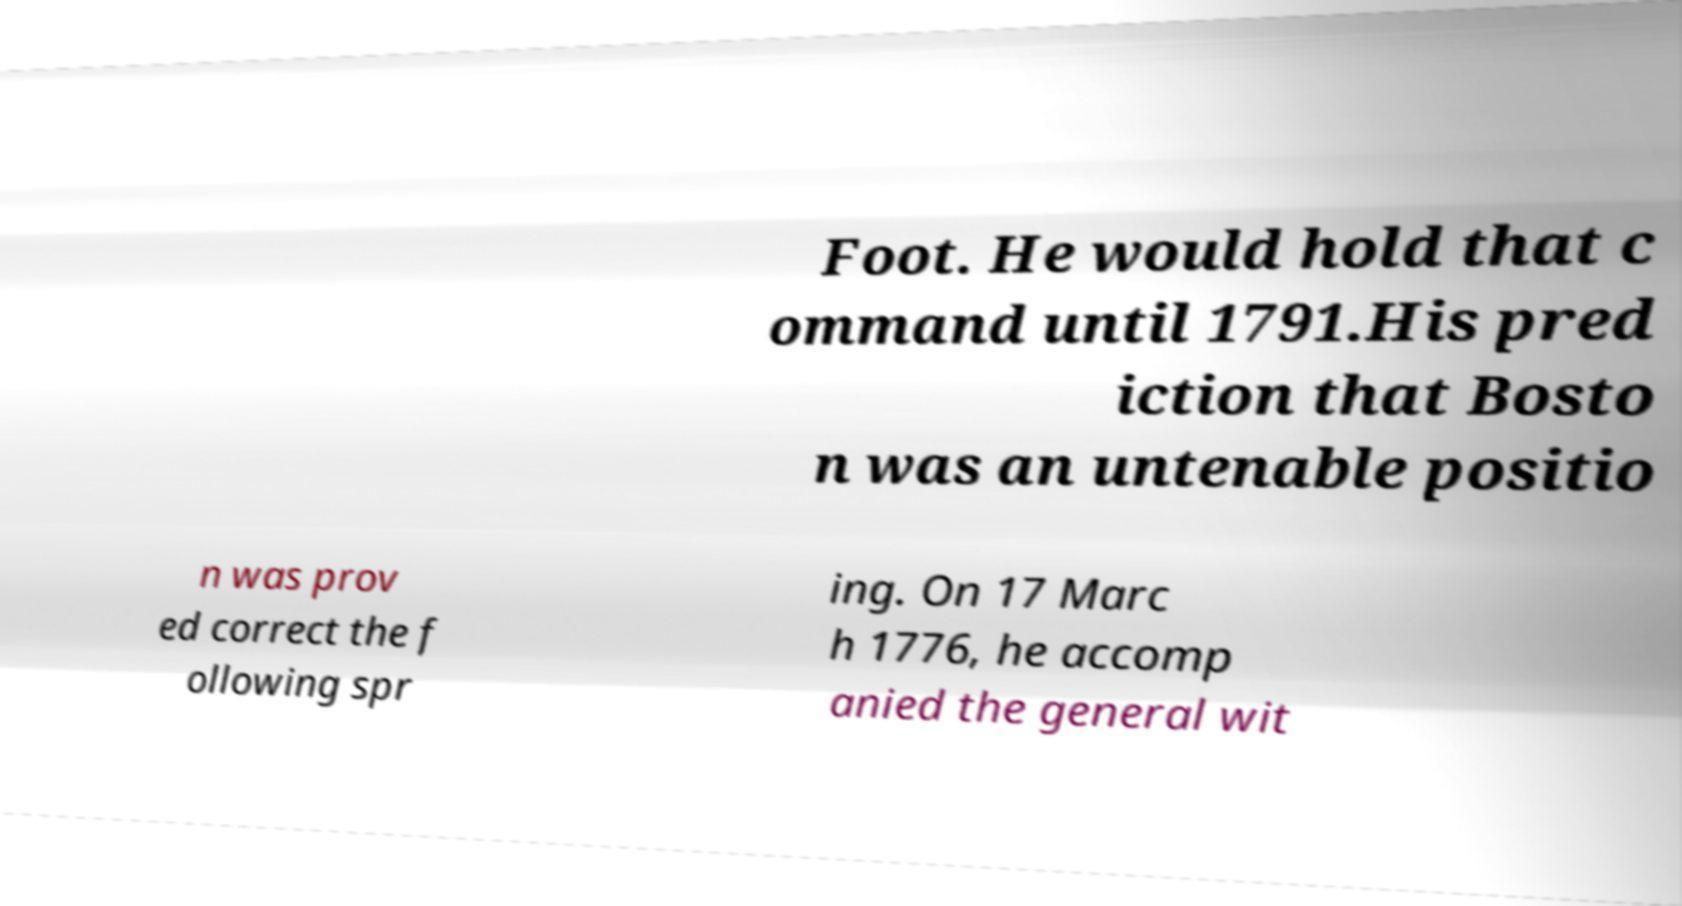There's text embedded in this image that I need extracted. Can you transcribe it verbatim? Foot. He would hold that c ommand until 1791.His pred iction that Bosto n was an untenable positio n was prov ed correct the f ollowing spr ing. On 17 Marc h 1776, he accomp anied the general wit 